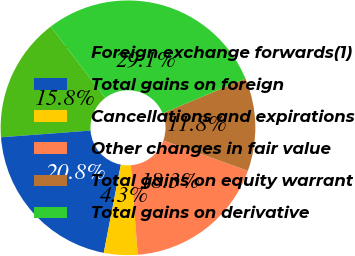Convert chart to OTSL. <chart><loc_0><loc_0><loc_500><loc_500><pie_chart><fcel>Foreign exchange forwards(1)<fcel>Total gains on foreign<fcel>Cancellations and expirations<fcel>Other changes in fair value<fcel>Total gains on equity warrant<fcel>Total gains on derivative<nl><fcel>15.81%<fcel>20.77%<fcel>4.27%<fcel>18.29%<fcel>11.81%<fcel>29.06%<nl></chart> 